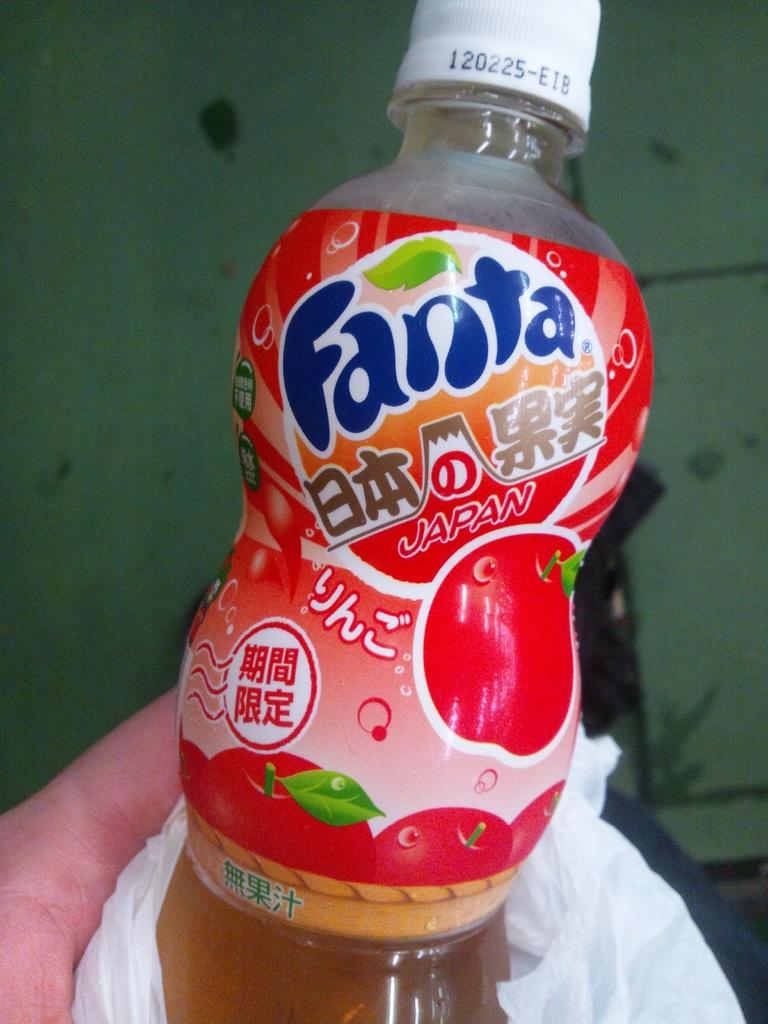<image>
Render a clear and concise summary of the photo. A red bottle of Fanta was made in Japan. 